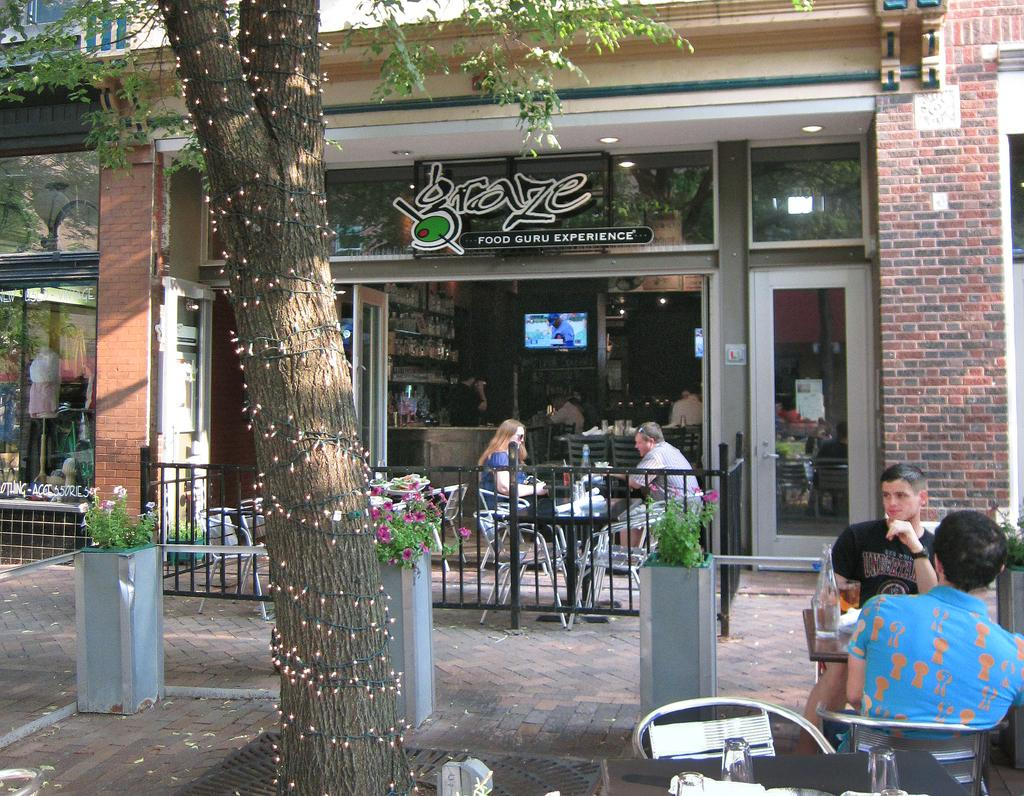What are the persons in the image doing? The persons in the image are sitting on chairs. What objects can be seen on the table? There are bottles and glasses on the table. What can be seen in the background of the image? There is a wall, a glass door, chairs, a television, and a tree visible in the background. What type of slope can be seen in the image? There is no slope present in the image. What kind of bun is being prepared in the image? There is no bun or any food preparation visible in the image. 